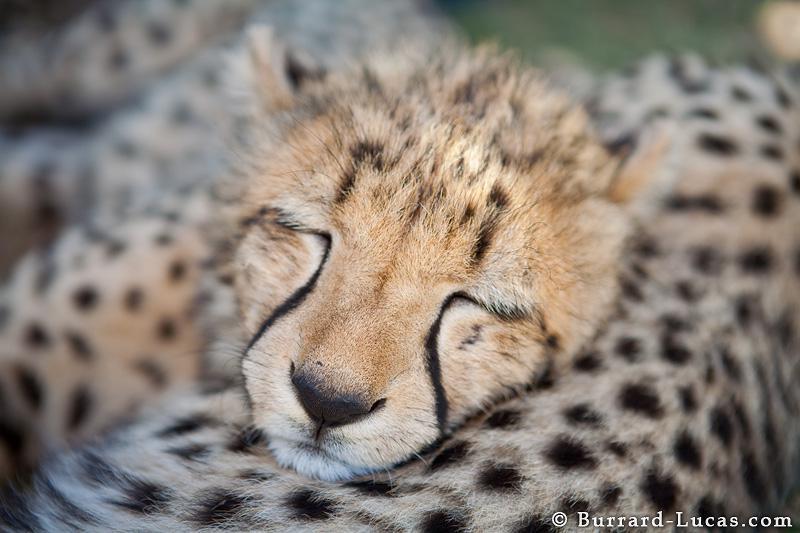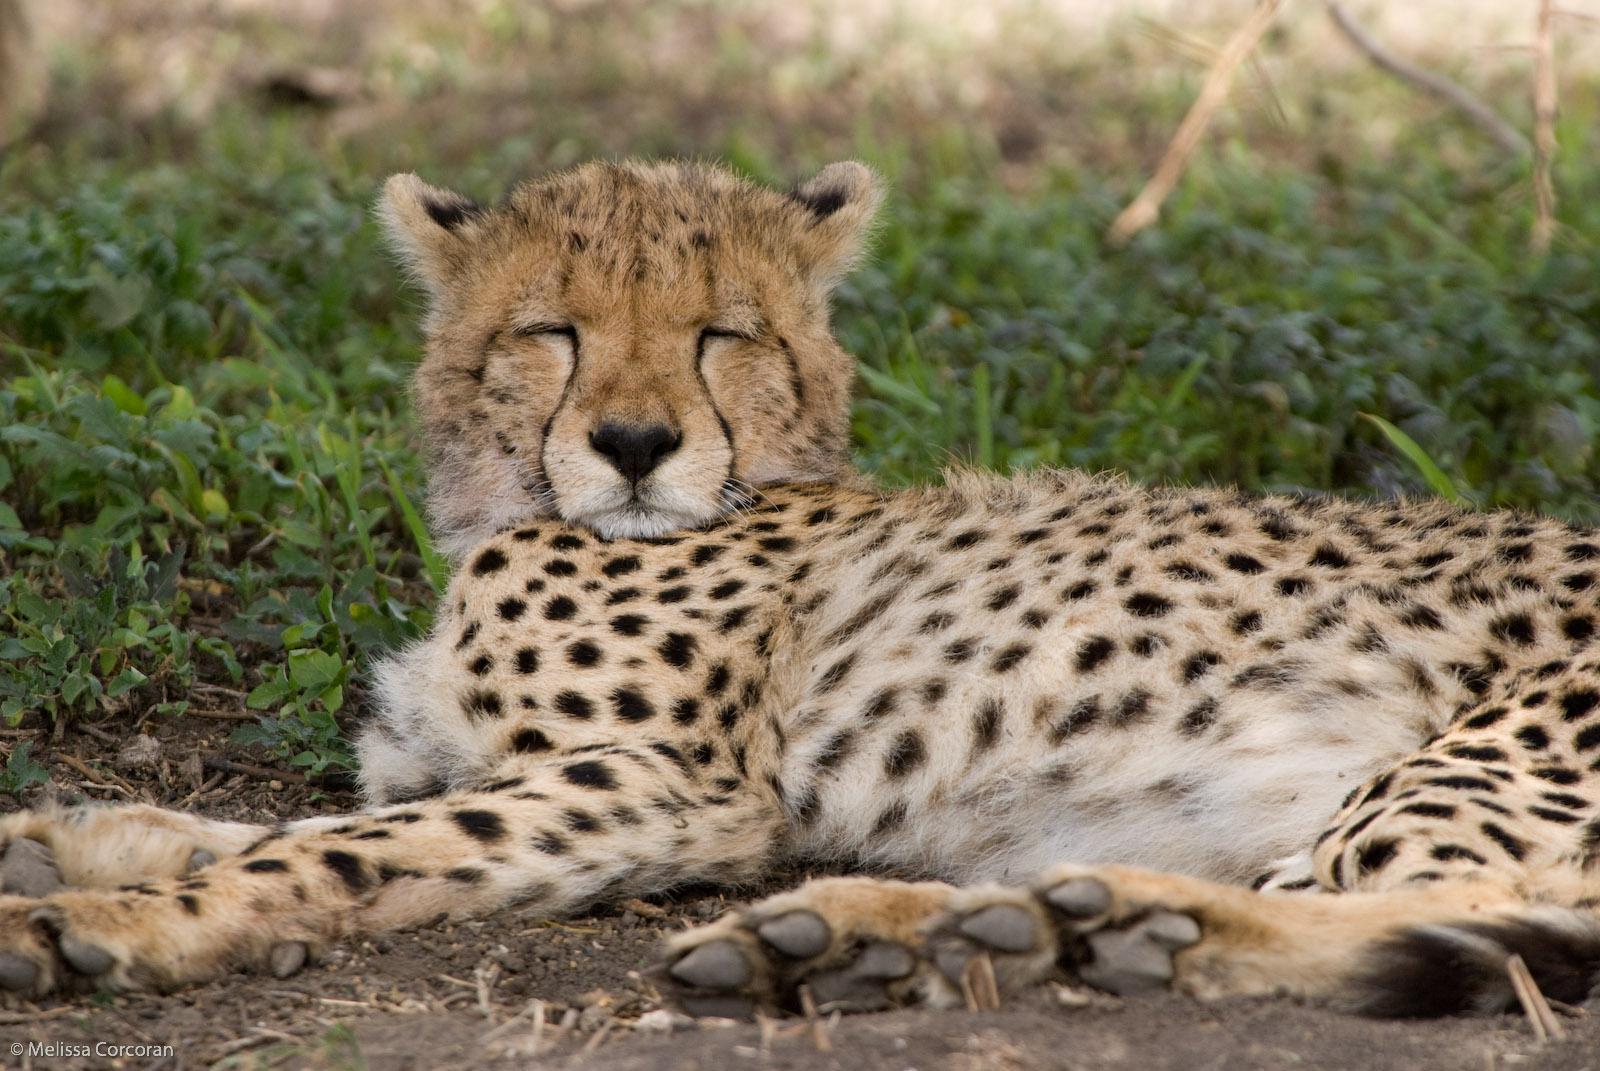The first image is the image on the left, the second image is the image on the right. For the images shown, is this caption "The cat in the image on the right has its mouth open wide." true? Answer yes or no. No. The first image is the image on the left, the second image is the image on the right. Evaluate the accuracy of this statement regarding the images: "One of the cheetahs is yawning". Is it true? Answer yes or no. No. 